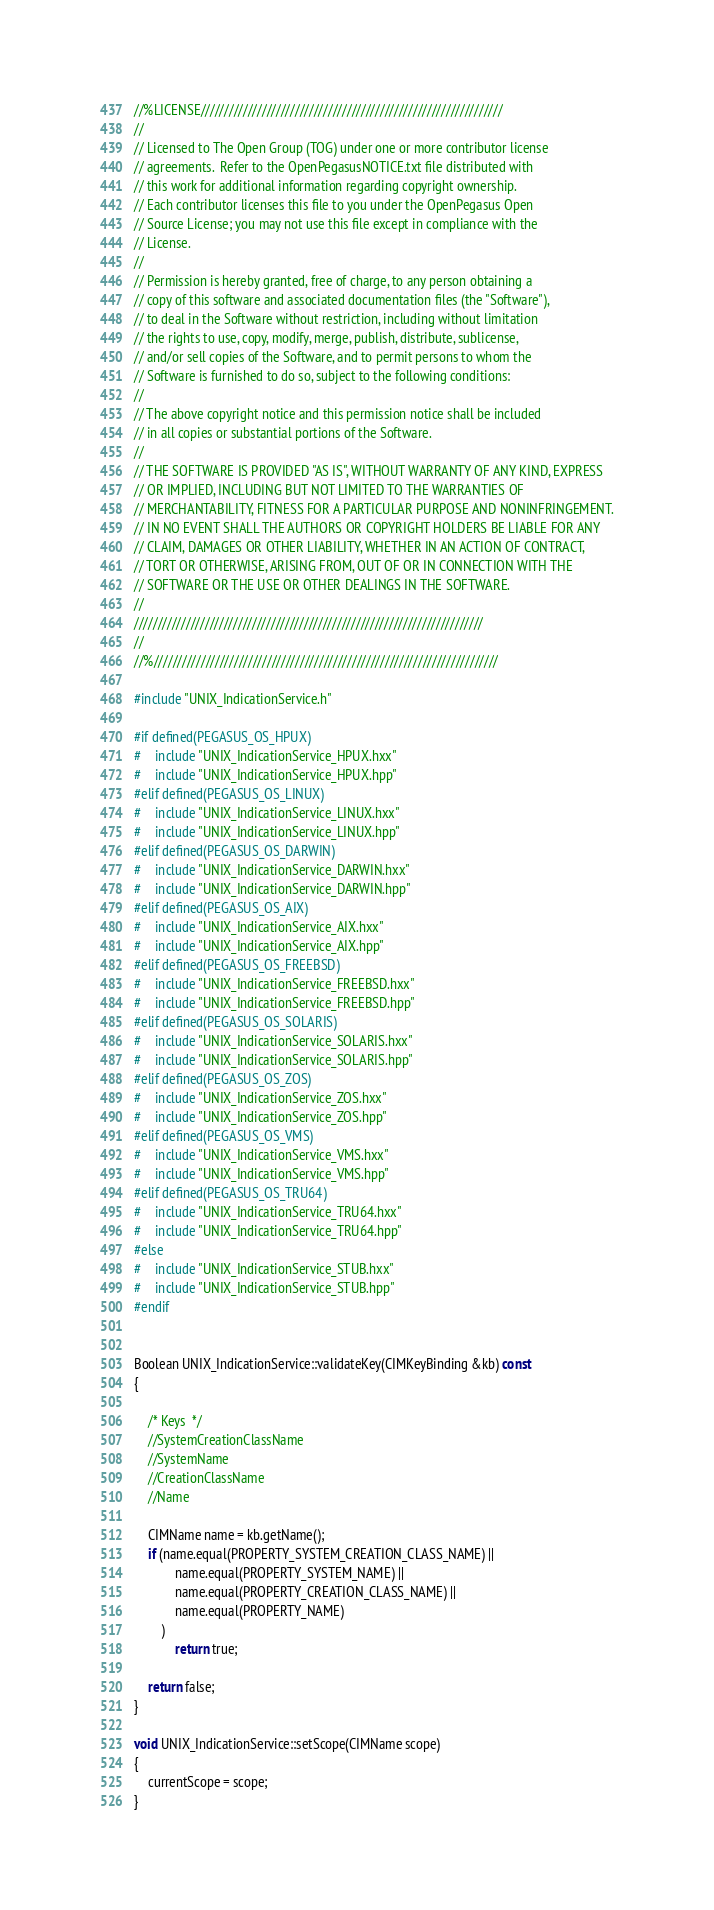<code> <loc_0><loc_0><loc_500><loc_500><_C++_>//%LICENSE////////////////////////////////////////////////////////////////
//
// Licensed to The Open Group (TOG) under one or more contributor license
// agreements.  Refer to the OpenPegasusNOTICE.txt file distributed with
// this work for additional information regarding copyright ownership.
// Each contributor licenses this file to you under the OpenPegasus Open
// Source License; you may not use this file except in compliance with the
// License.
//
// Permission is hereby granted, free of charge, to any person obtaining a
// copy of this software and associated documentation files (the "Software"),
// to deal in the Software without restriction, including without limitation
// the rights to use, copy, modify, merge, publish, distribute, sublicense,
// and/or sell copies of the Software, and to permit persons to whom the
// Software is furnished to do so, subject to the following conditions:
//
// The above copyright notice and this permission notice shall be included
// in all copies or substantial portions of the Software.
//
// THE SOFTWARE IS PROVIDED "AS IS", WITHOUT WARRANTY OF ANY KIND, EXPRESS
// OR IMPLIED, INCLUDING BUT NOT LIMITED TO THE WARRANTIES OF
// MERCHANTABILITY, FITNESS FOR A PARTICULAR PURPOSE AND NONINFRINGEMENT.
// IN NO EVENT SHALL THE AUTHORS OR COPYRIGHT HOLDERS BE LIABLE FOR ANY
// CLAIM, DAMAGES OR OTHER LIABILITY, WHETHER IN AN ACTION OF CONTRACT,
// TORT OR OTHERWISE, ARISING FROM, OUT OF OR IN CONNECTION WITH THE
// SOFTWARE OR THE USE OR OTHER DEALINGS IN THE SOFTWARE.
//
//////////////////////////////////////////////////////////////////////////
//
//%/////////////////////////////////////////////////////////////////////////

#include "UNIX_IndicationService.h"

#if defined(PEGASUS_OS_HPUX)
#	include "UNIX_IndicationService_HPUX.hxx"
#	include "UNIX_IndicationService_HPUX.hpp"
#elif defined(PEGASUS_OS_LINUX)
#	include "UNIX_IndicationService_LINUX.hxx"
#	include "UNIX_IndicationService_LINUX.hpp"
#elif defined(PEGASUS_OS_DARWIN)
#	include "UNIX_IndicationService_DARWIN.hxx"
#	include "UNIX_IndicationService_DARWIN.hpp"
#elif defined(PEGASUS_OS_AIX)
#	include "UNIX_IndicationService_AIX.hxx"
#	include "UNIX_IndicationService_AIX.hpp"
#elif defined(PEGASUS_OS_FREEBSD)
#	include "UNIX_IndicationService_FREEBSD.hxx"
#	include "UNIX_IndicationService_FREEBSD.hpp"
#elif defined(PEGASUS_OS_SOLARIS)
#	include "UNIX_IndicationService_SOLARIS.hxx"
#	include "UNIX_IndicationService_SOLARIS.hpp"
#elif defined(PEGASUS_OS_ZOS)
#	include "UNIX_IndicationService_ZOS.hxx"
#	include "UNIX_IndicationService_ZOS.hpp"
#elif defined(PEGASUS_OS_VMS)
#	include "UNIX_IndicationService_VMS.hxx"
#	include "UNIX_IndicationService_VMS.hpp"
#elif defined(PEGASUS_OS_TRU64)
#	include "UNIX_IndicationService_TRU64.hxx"
#	include "UNIX_IndicationService_TRU64.hpp"
#else
#	include "UNIX_IndicationService_STUB.hxx"
#	include "UNIX_IndicationService_STUB.hpp"
#endif


Boolean UNIX_IndicationService::validateKey(CIMKeyBinding &kb) const
{

	/* Keys  */
	//SystemCreationClassName
	//SystemName
	//CreationClassName
	//Name

	CIMName name = kb.getName();
	if (name.equal(PROPERTY_SYSTEM_CREATION_CLASS_NAME) ||
			name.equal(PROPERTY_SYSTEM_NAME) ||
			name.equal(PROPERTY_CREATION_CLASS_NAME) ||
			name.equal(PROPERTY_NAME)
		)
			return true;

	return false;
}

void UNIX_IndicationService::setScope(CIMName scope)
{
	currentScope = scope;
}

</code> 